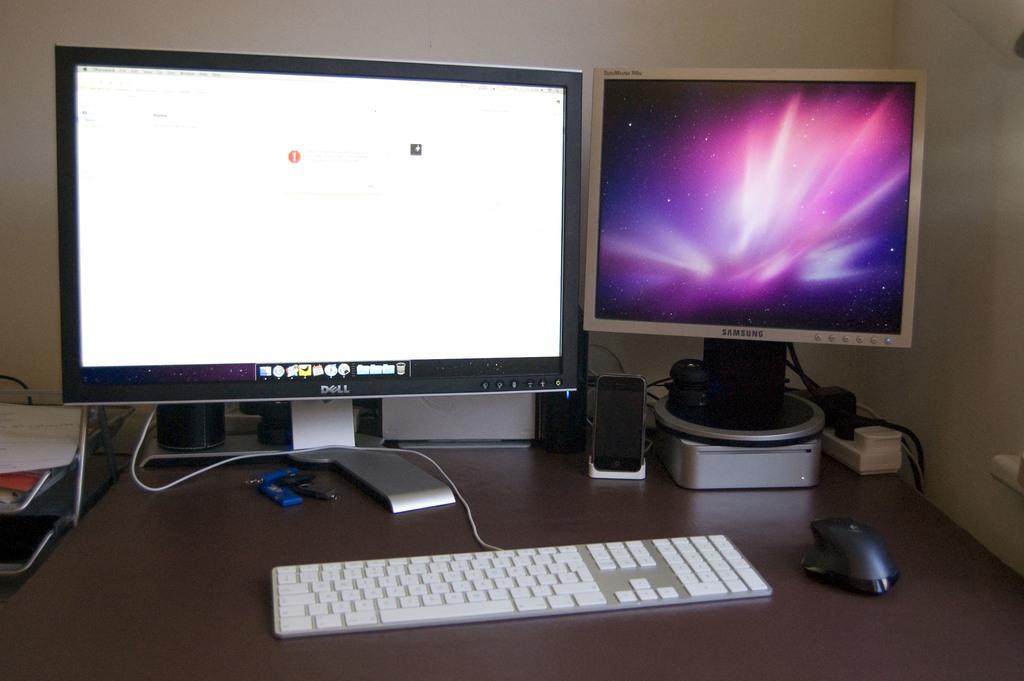How would you summarize this image in a sentence or two? In the picture I can see two monitors, speaker boxes, mouse, keyboard, keychain and few more objects are placed on the table. In the background, I can see the wall. 